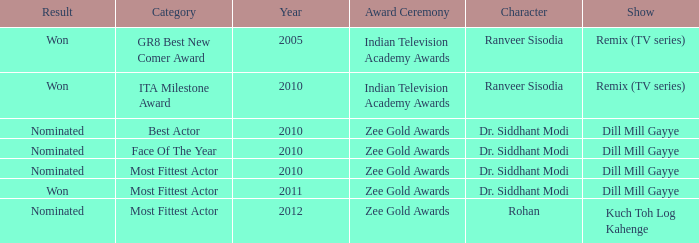Which program features a character named rohan? Kuch Toh Log Kahenge. 